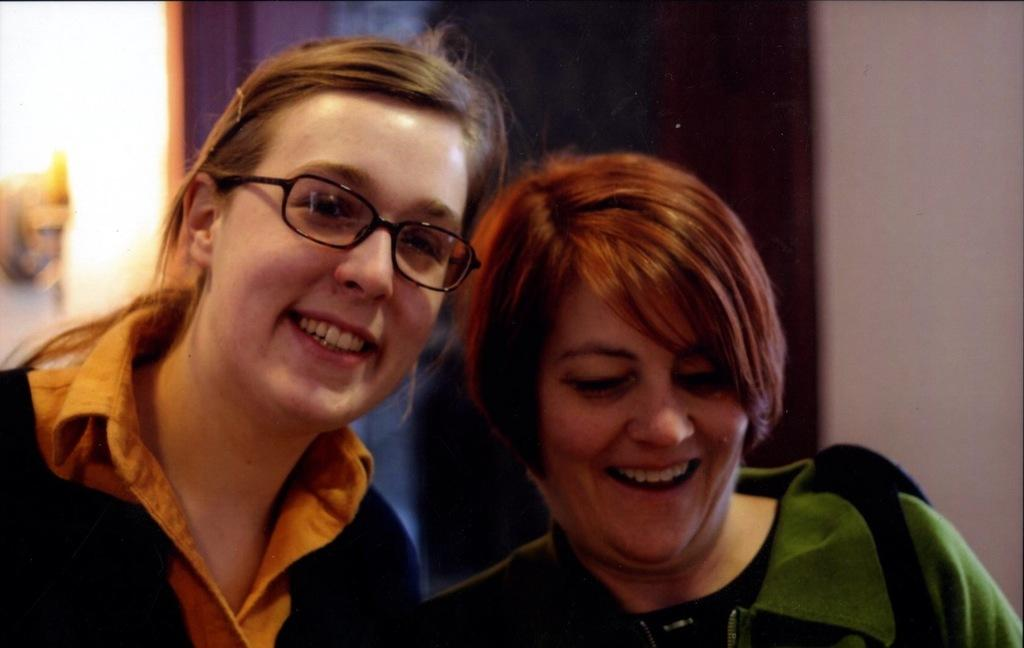Who are the main subjects in the image? There are women in the center of the image. What can be seen behind the women? There is a wall in the background of the image. How many eyes can be seen on the sink in the image? There is no sink present in the image, and therefore no eyes can be seen on it. 